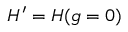Convert formula to latex. <formula><loc_0><loc_0><loc_500><loc_500>H ^ { \prime } = H ( g = 0 )</formula> 